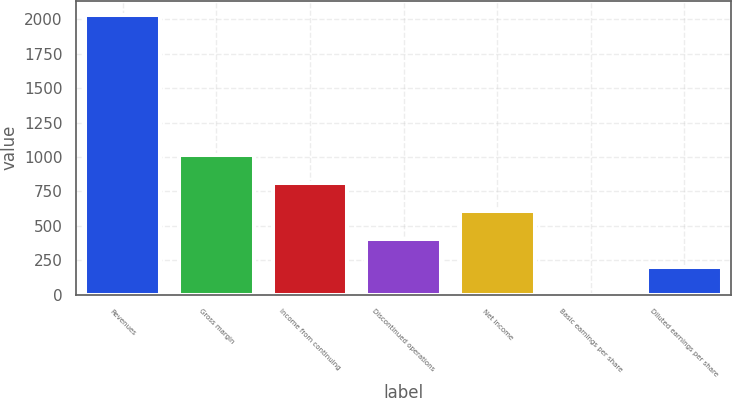Convert chart. <chart><loc_0><loc_0><loc_500><loc_500><bar_chart><fcel>Revenues<fcel>Gross margin<fcel>Income from continuing<fcel>Discontinued operations<fcel>Net income<fcel>Basic earnings per share<fcel>Diluted earnings per share<nl><fcel>2035<fcel>1017.61<fcel>814.13<fcel>407.17<fcel>610.65<fcel>0.21<fcel>203.69<nl></chart> 